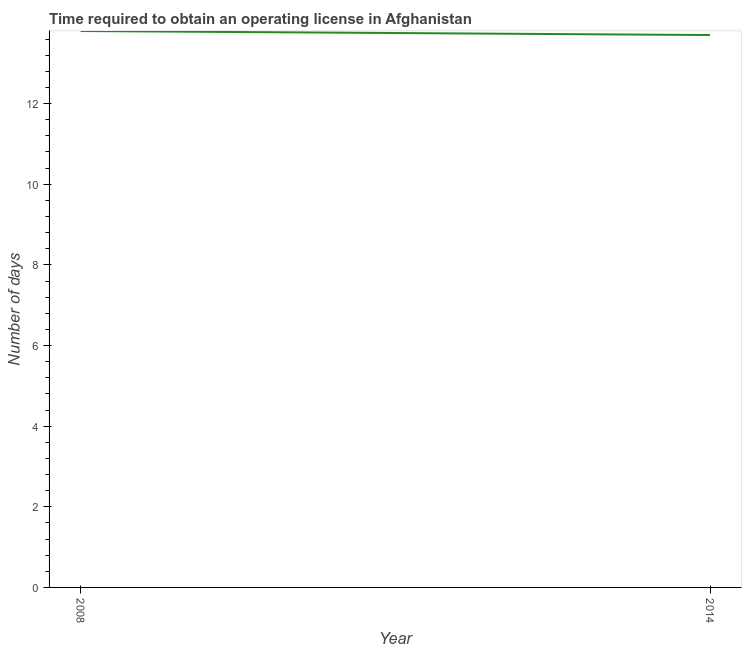What is the number of days to obtain operating license in 2008?
Offer a terse response. 13.8. Across all years, what is the minimum number of days to obtain operating license?
Ensure brevity in your answer.  13.7. What is the sum of the number of days to obtain operating license?
Offer a very short reply. 27.5. What is the difference between the number of days to obtain operating license in 2008 and 2014?
Provide a short and direct response. 0.1. What is the average number of days to obtain operating license per year?
Keep it short and to the point. 13.75. What is the median number of days to obtain operating license?
Provide a short and direct response. 13.75. In how many years, is the number of days to obtain operating license greater than 2.4 days?
Your answer should be compact. 2. Do a majority of the years between 2014 and 2008 (inclusive) have number of days to obtain operating license greater than 12 days?
Give a very brief answer. No. What is the ratio of the number of days to obtain operating license in 2008 to that in 2014?
Your answer should be very brief. 1.01. In how many years, is the number of days to obtain operating license greater than the average number of days to obtain operating license taken over all years?
Your answer should be very brief. 1. How many lines are there?
Give a very brief answer. 1. Are the values on the major ticks of Y-axis written in scientific E-notation?
Provide a succinct answer. No. Does the graph contain grids?
Make the answer very short. No. What is the title of the graph?
Ensure brevity in your answer.  Time required to obtain an operating license in Afghanistan. What is the label or title of the Y-axis?
Offer a very short reply. Number of days. What is the Number of days in 2008?
Provide a short and direct response. 13.8. What is the difference between the Number of days in 2008 and 2014?
Offer a terse response. 0.1. 